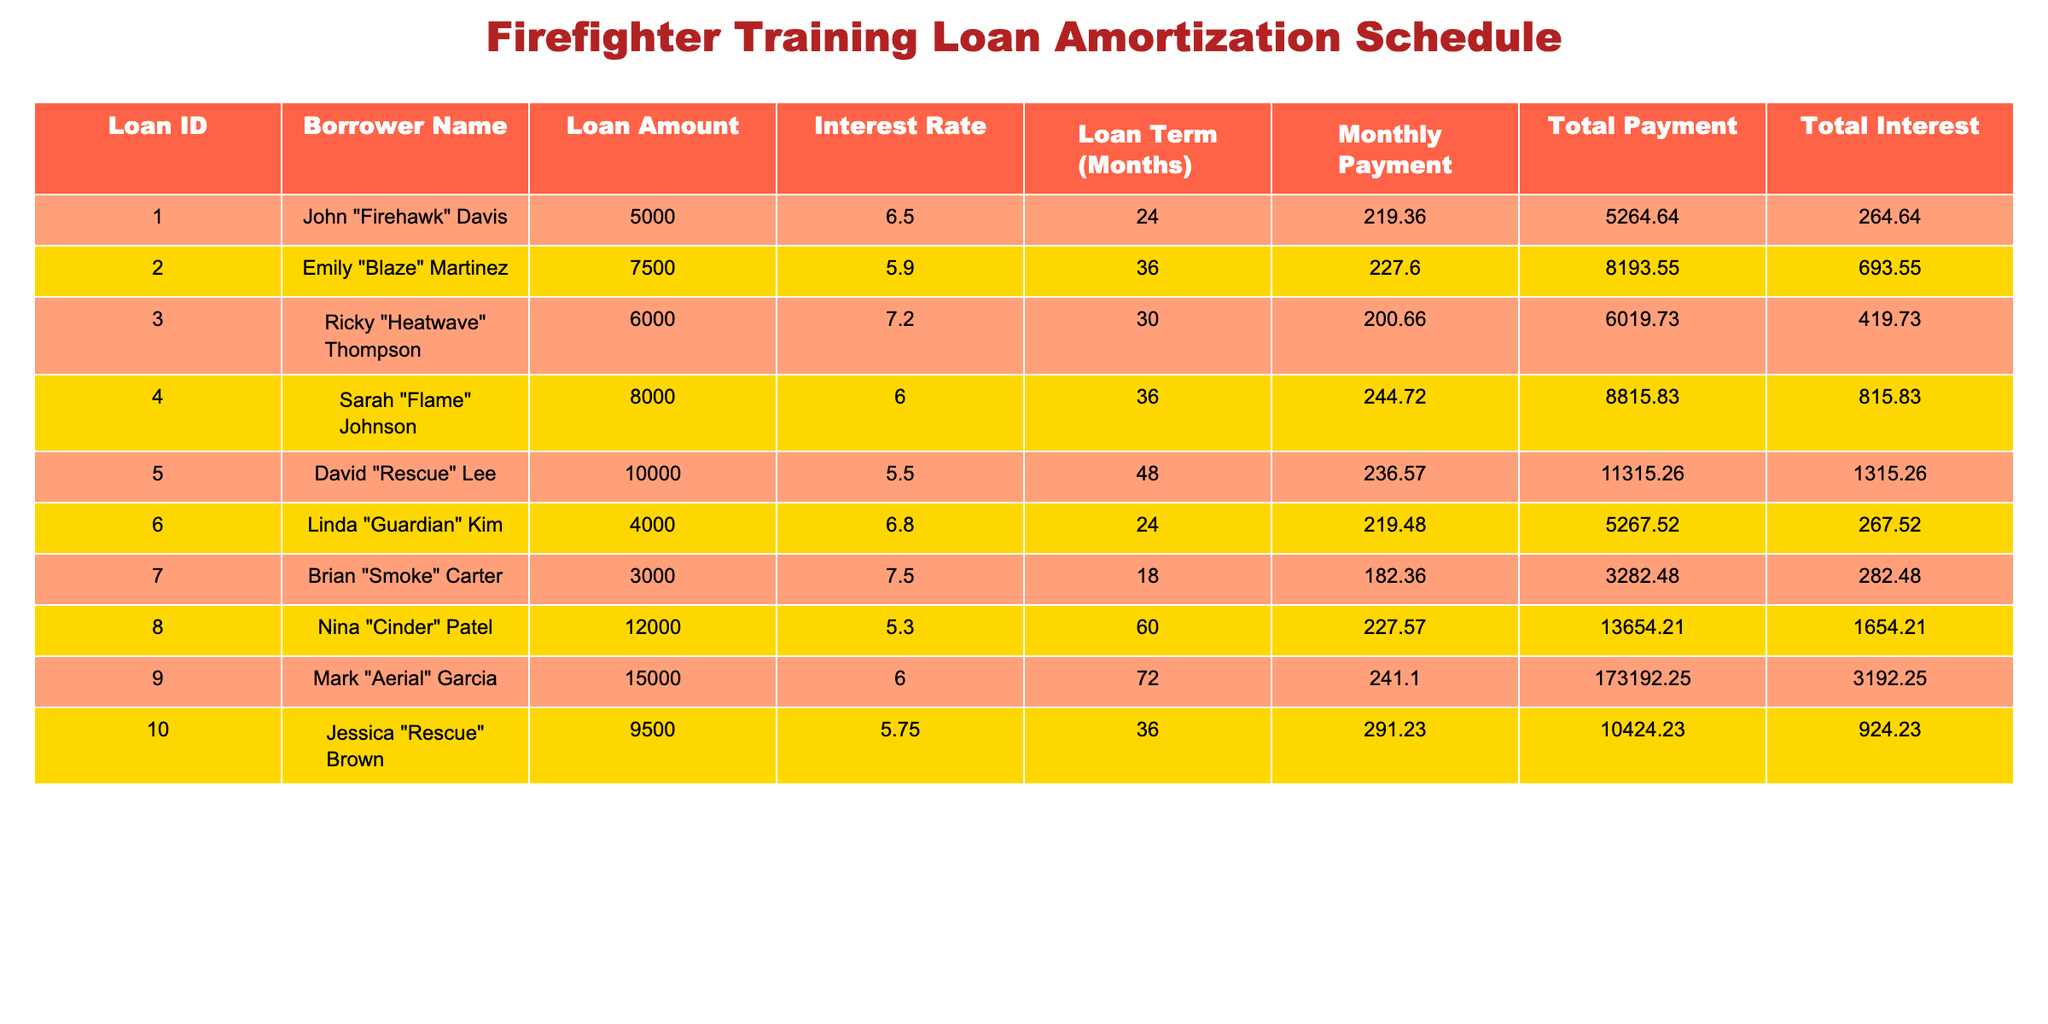What is the highest loan amount in the table? The loan amounts are: 5000, 7500, 6000, 8000, 10000, 4000, 3000, 12000, 15000, and 9500. The highest among these is 15000.
Answer: 15000 Who has the lowest total payment in the table? The total payments are: 5264.64, 8193.55, 6019.73, 8815.83, 11315.26, 5267.52, 3282.48, 13654.21, 173192.25, and 10424.23. The lowest total payment is 3282.48, made by Brian "Smoke" Carter.
Answer: Brian "Smoke" Carter What is the average interest rate of all the loans? The interest rates are: 6.5, 5.9, 7.2, 6.0, 5.5, 6.8, 7.5, 5.3, 6.0, and 5.75. First, we calculate the sum: 6.5 + 5.9 + 7.2 + 6.0 + 5.5 + 6.8 + 7.5 + 5.3 + 6.0 + 5.75 = 6.325. There are 10 loans, so the average interest rate is 63.25 / 10 = 6.325.
Answer: 6.325 Is Jessica "Rescue" Brown's total interest greater than David "Rescue" Lee's total interest? Jessica "Rescue" Brown's total interest is 924.23 and David "Rescue" Lee's total interest is 1315.26. Since 924.23 is less than 1315.26, the statement is false.
Answer: No If we sum the loan amounts of Sarah "Flame" Johnson and Ricky "Heatwave" Thompson, what is the total? Sarah "Flame" Johnson's loan amount is 8000 and Ricky "Heatwave" Thompson's loan amount is 6000. Adding these amounts together gives us 8000 + 6000 = 14000.
Answer: 14000 Which borrower has a loan term of 60 months? Looking at the loan terms, only Nina "Cinder" Patel has a loan term of 60 months, while the others have shorter terms.
Answer: Nina "Cinder" Patel What is the total payment for the loan with the highest interest rate? The highest interest rate in the list is 7.5%, which belongs to Brian "Smoke" Carter who has a total payment of 3282.48.
Answer: 3282.48 Which borrowers have a monthly payment greater than 240? The monthly payments are: 219.36, 227.60, 200.66, 244.72, 236.57, 219.48, 182.36, 227.57, 241.10, and 291.23. Monthly payments greater than 240 are made by Sarah "Flame" Johnson (244.72) and Jessica "Rescue" Brown (291.23).
Answer: Sarah "Flame" Johnson, Jessica "Rescue" Brown What is the difference in total interest between the loan for John "Firehawk" Davis and that for Emily "Blaze" Martinez? John "Firehawk" Davis has a total interest of 264.64 and Emily "Blaze" Martinez has a total interest of 693.55. The difference in total interest is 693.55 - 264.64 = 428.91.
Answer: 428.91 